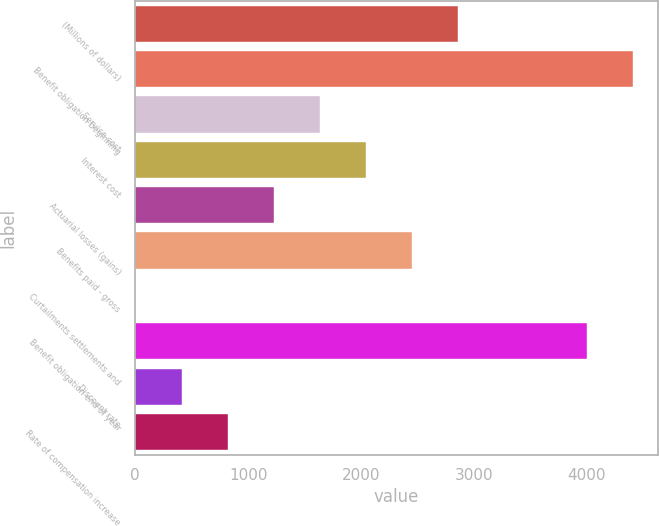<chart> <loc_0><loc_0><loc_500><loc_500><bar_chart><fcel>(Millions of dollars)<fcel>Benefit obligation beginning<fcel>Service cost<fcel>Interest cost<fcel>Actuarial losses (gains)<fcel>Benefits paid - gross<fcel>Curtailments settlements and<fcel>Benefit obligation end of year<fcel>Discount rate<fcel>Rate of compensation increase<nl><fcel>2862.2<fcel>4410.6<fcel>1636.4<fcel>2045<fcel>1227.8<fcel>2453.6<fcel>2<fcel>4002<fcel>410.6<fcel>819.2<nl></chart> 